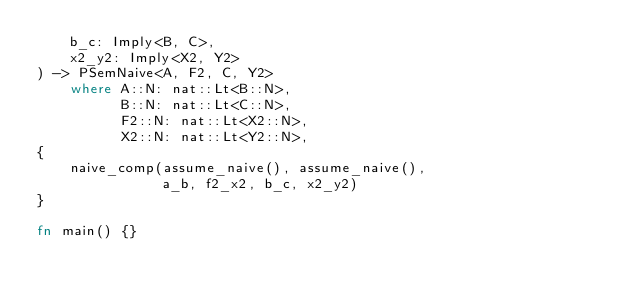<code> <loc_0><loc_0><loc_500><loc_500><_Rust_>    b_c: Imply<B, C>,
    x2_y2: Imply<X2, Y2>
) -> PSemNaive<A, F2, C, Y2>
    where A::N: nat::Lt<B::N>,
          B::N: nat::Lt<C::N>,
          F2::N: nat::Lt<X2::N>,
          X2::N: nat::Lt<Y2::N>,
{
    naive_comp(assume_naive(), assume_naive(),
               a_b, f2_x2, b_c, x2_y2)
}

fn main() {}
</code> 